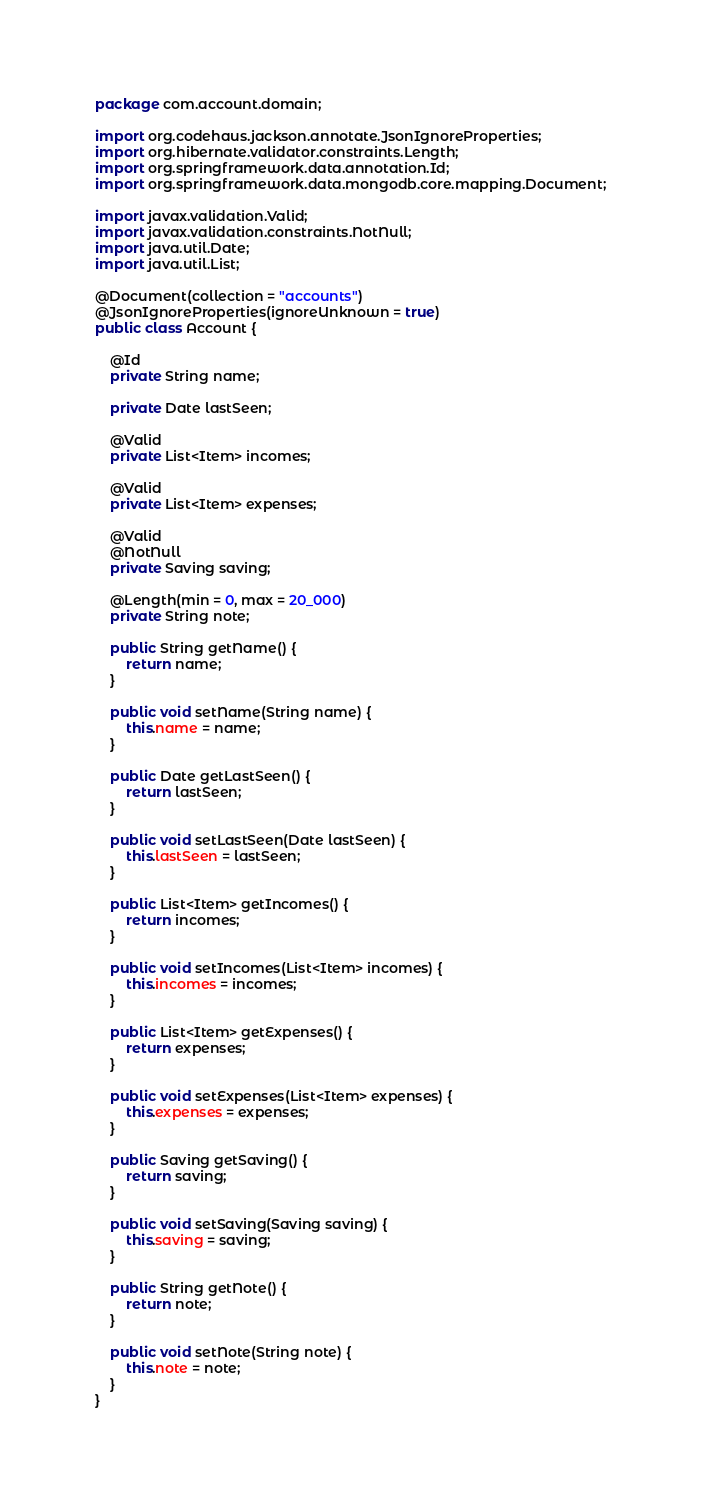<code> <loc_0><loc_0><loc_500><loc_500><_Java_>package com.account.domain;

import org.codehaus.jackson.annotate.JsonIgnoreProperties;
import org.hibernate.validator.constraints.Length;
import org.springframework.data.annotation.Id;
import org.springframework.data.mongodb.core.mapping.Document;

import javax.validation.Valid;
import javax.validation.constraints.NotNull;
import java.util.Date;
import java.util.List;

@Document(collection = "accounts")
@JsonIgnoreProperties(ignoreUnknown = true)
public class Account {

    @Id
    private String name;

    private Date lastSeen;

    @Valid
    private List<Item> incomes;

    @Valid
    private List<Item> expenses;

    @Valid
    @NotNull
    private Saving saving;

    @Length(min = 0, max = 20_000)
    private String note;

    public String getName() {
        return name;
    }

    public void setName(String name) {
        this.name = name;
    }

    public Date getLastSeen() {
        return lastSeen;
    }

    public void setLastSeen(Date lastSeen) {
        this.lastSeen = lastSeen;
    }

    public List<Item> getIncomes() {
        return incomes;
    }

    public void setIncomes(List<Item> incomes) {
        this.incomes = incomes;
    }

    public List<Item> getExpenses() {
        return expenses;
    }

    public void setExpenses(List<Item> expenses) {
        this.expenses = expenses;
    }

    public Saving getSaving() {
        return saving;
    }

    public void setSaving(Saving saving) {
        this.saving = saving;
    }

    public String getNote() {
        return note;
    }

    public void setNote(String note) {
        this.note = note;
    }
}
</code> 